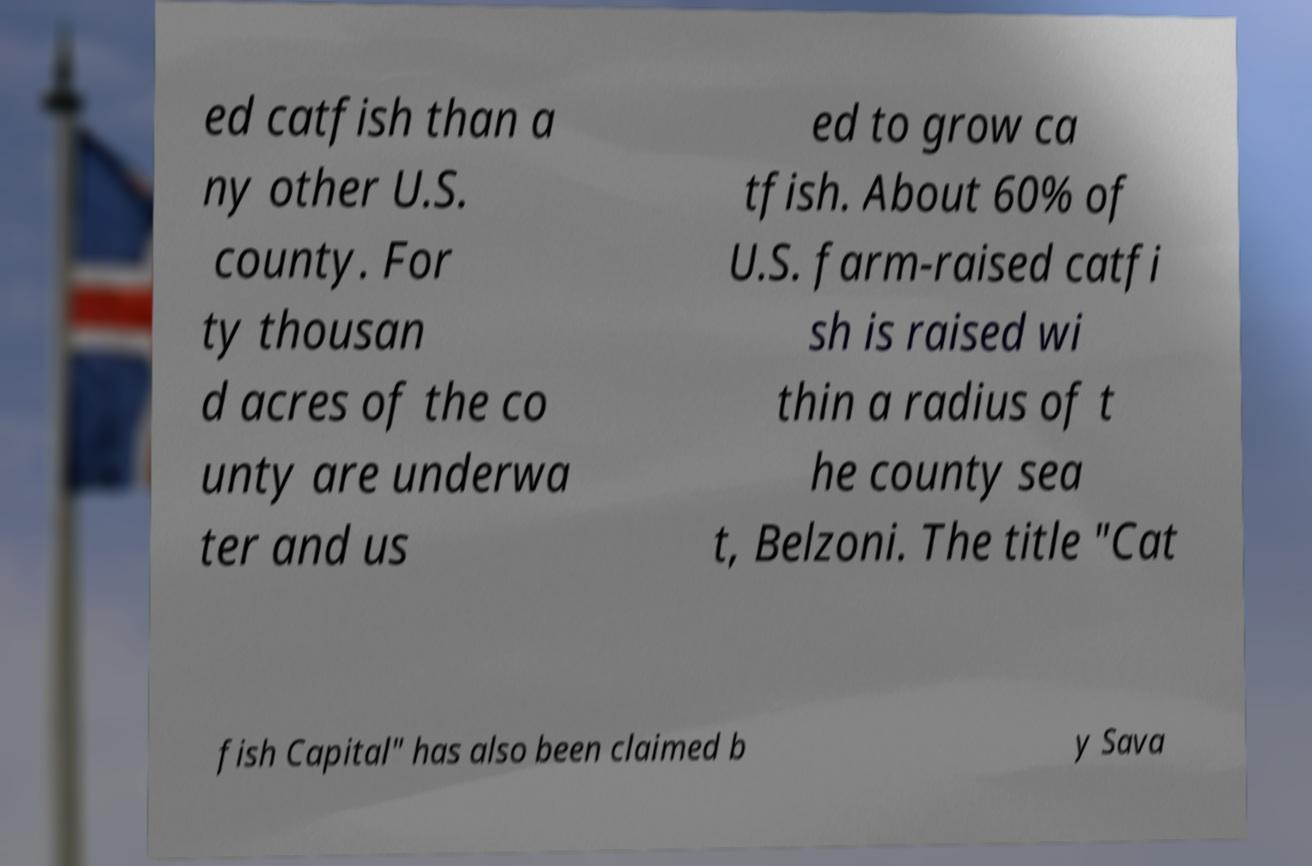Can you read and provide the text displayed in the image?This photo seems to have some interesting text. Can you extract and type it out for me? ed catfish than a ny other U.S. county. For ty thousan d acres of the co unty are underwa ter and us ed to grow ca tfish. About 60% of U.S. farm-raised catfi sh is raised wi thin a radius of t he county sea t, Belzoni. The title "Cat fish Capital" has also been claimed b y Sava 